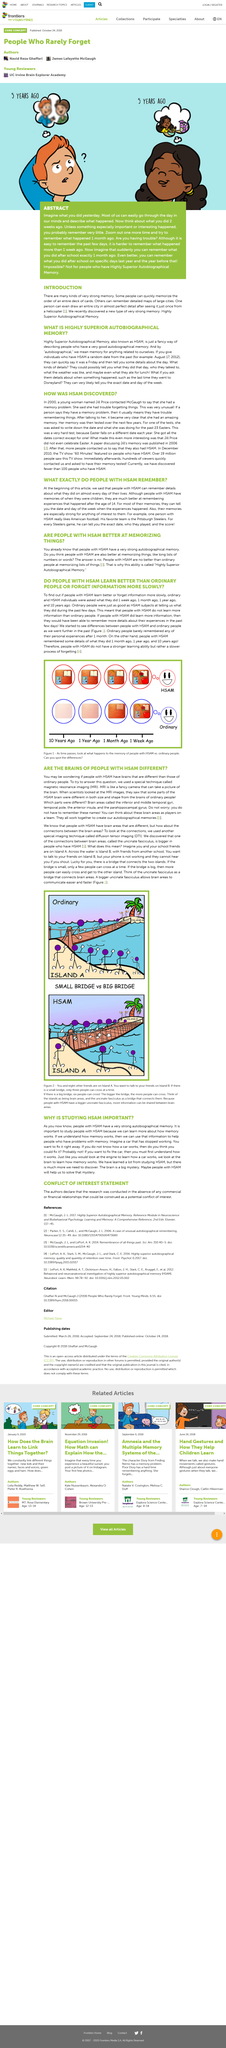Specify some key components in this picture. Individuals have a greater ability to recall past events when they possess Highly Superior Autobiographical Memory. People with Highly Superior Autobiographical Memory (HSAM) are able to recall specific details about their past experiences on almost every day of their lives. People with Highly Superior Autobiographical Memory (HSAM) tend to have an exceptional ability to remember past events and personal experiences, with many reportedly being able to recall specific details from their childhood or even earlier in life. According to research, the average age at which people with HSAM show significant improvement in their memory abilities is around 14 years old. Highly Superior Autobiographical Memory is a term used to describe individuals who possess an exceptional ability to recall details from their personal past. HSAM stands for Highly Superior Autobiographical Memory, a term used to describe an exceptional memory for one's own personal experiences and events. 